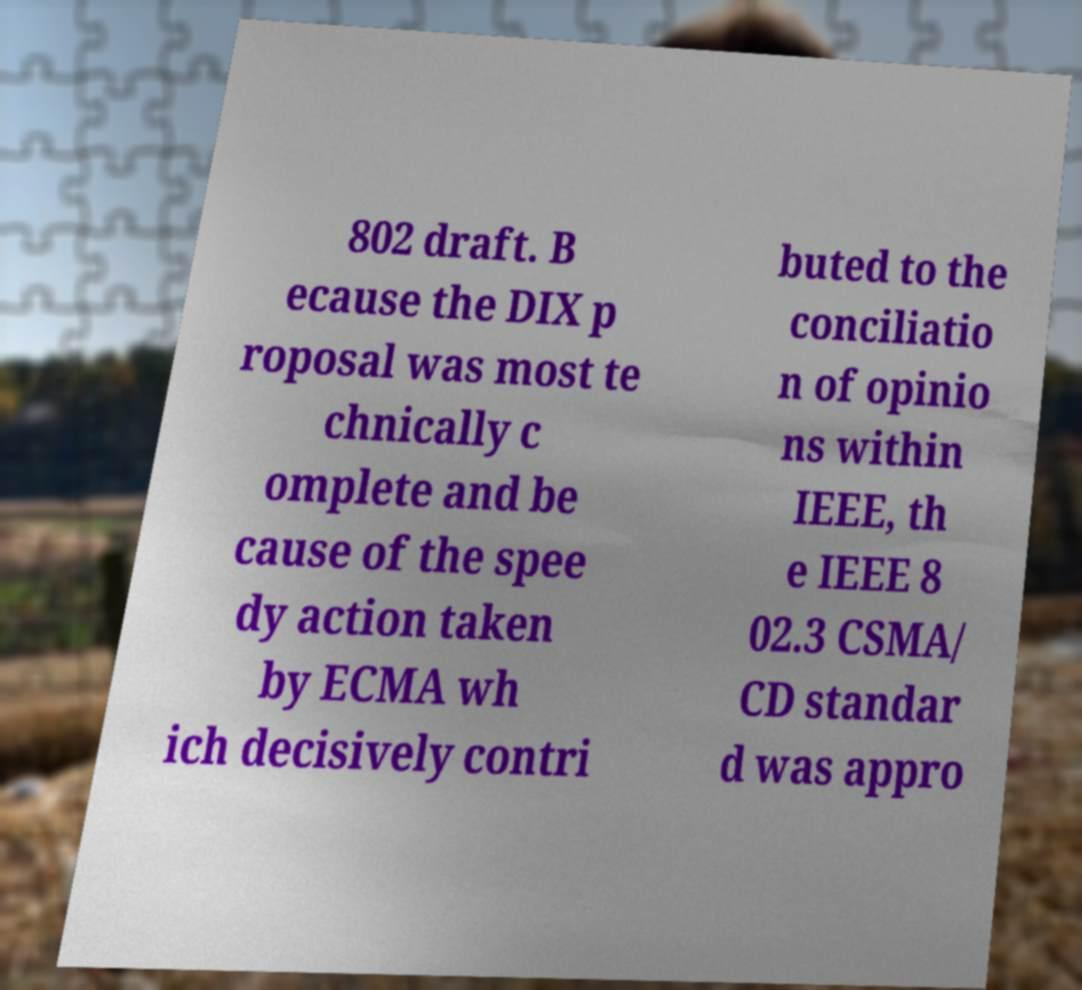Can you accurately transcribe the text from the provided image for me? 802 draft. B ecause the DIX p roposal was most te chnically c omplete and be cause of the spee dy action taken by ECMA wh ich decisively contri buted to the conciliatio n of opinio ns within IEEE, th e IEEE 8 02.3 CSMA/ CD standar d was appro 